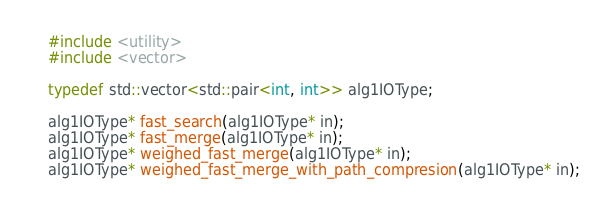<code> <loc_0><loc_0><loc_500><loc_500><_C++_>#include <utility>
#include <vector>

typedef std::vector<std::pair<int, int>> alg1IOType;

alg1IOType* fast_search(alg1IOType* in);
alg1IOType* fast_merge(alg1IOType* in);
alg1IOType* weighed_fast_merge(alg1IOType* in);
alg1IOType* weighed_fast_merge_with_path_compresion(alg1IOType* in);</code> 